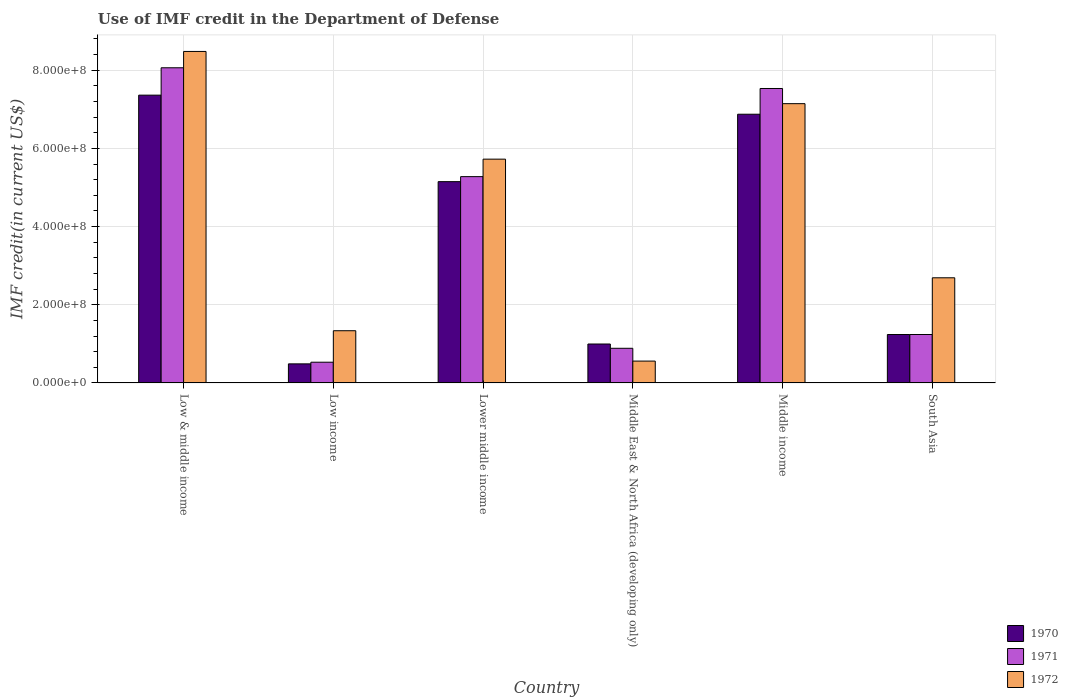How many different coloured bars are there?
Make the answer very short. 3. Are the number of bars per tick equal to the number of legend labels?
Provide a short and direct response. Yes. How many bars are there on the 6th tick from the left?
Ensure brevity in your answer.  3. What is the IMF credit in the Department of Defense in 1971 in Middle income?
Your answer should be compact. 7.53e+08. Across all countries, what is the maximum IMF credit in the Department of Defense in 1970?
Your answer should be compact. 7.36e+08. Across all countries, what is the minimum IMF credit in the Department of Defense in 1970?
Give a very brief answer. 4.88e+07. What is the total IMF credit in the Department of Defense in 1970 in the graph?
Your response must be concise. 2.21e+09. What is the difference between the IMF credit in the Department of Defense in 1971 in Low & middle income and that in Lower middle income?
Your answer should be very brief. 2.79e+08. What is the difference between the IMF credit in the Department of Defense in 1972 in South Asia and the IMF credit in the Department of Defense in 1970 in Middle East & North Africa (developing only)?
Your answer should be compact. 1.69e+08. What is the average IMF credit in the Department of Defense in 1972 per country?
Make the answer very short. 4.32e+08. What is the difference between the IMF credit in the Department of Defense of/in 1972 and IMF credit in the Department of Defense of/in 1970 in Middle East & North Africa (developing only)?
Make the answer very short. -4.37e+07. In how many countries, is the IMF credit in the Department of Defense in 1972 greater than 840000000 US$?
Provide a short and direct response. 1. What is the ratio of the IMF credit in the Department of Defense in 1970 in Low & middle income to that in Middle income?
Your answer should be very brief. 1.07. Is the difference between the IMF credit in the Department of Defense in 1972 in Low & middle income and Low income greater than the difference between the IMF credit in the Department of Defense in 1970 in Low & middle income and Low income?
Provide a succinct answer. Yes. What is the difference between the highest and the second highest IMF credit in the Department of Defense in 1972?
Provide a succinct answer. 1.34e+08. What is the difference between the highest and the lowest IMF credit in the Department of Defense in 1970?
Provide a succinct answer. 6.87e+08. What does the 2nd bar from the right in Low & middle income represents?
Offer a terse response. 1971. Is it the case that in every country, the sum of the IMF credit in the Department of Defense in 1971 and IMF credit in the Department of Defense in 1970 is greater than the IMF credit in the Department of Defense in 1972?
Offer a very short reply. No. Are all the bars in the graph horizontal?
Keep it short and to the point. No. How many countries are there in the graph?
Provide a short and direct response. 6. Does the graph contain any zero values?
Keep it short and to the point. No. Does the graph contain grids?
Provide a short and direct response. Yes. How many legend labels are there?
Your response must be concise. 3. What is the title of the graph?
Your answer should be compact. Use of IMF credit in the Department of Defense. Does "1980" appear as one of the legend labels in the graph?
Your answer should be very brief. No. What is the label or title of the X-axis?
Your answer should be very brief. Country. What is the label or title of the Y-axis?
Your answer should be very brief. IMF credit(in current US$). What is the IMF credit(in current US$) of 1970 in Low & middle income?
Offer a very short reply. 7.36e+08. What is the IMF credit(in current US$) of 1971 in Low & middle income?
Make the answer very short. 8.06e+08. What is the IMF credit(in current US$) in 1972 in Low & middle income?
Your answer should be compact. 8.48e+08. What is the IMF credit(in current US$) of 1970 in Low income?
Your answer should be compact. 4.88e+07. What is the IMF credit(in current US$) of 1971 in Low income?
Give a very brief answer. 5.30e+07. What is the IMF credit(in current US$) of 1972 in Low income?
Provide a succinct answer. 1.34e+08. What is the IMF credit(in current US$) in 1970 in Lower middle income?
Offer a terse response. 5.15e+08. What is the IMF credit(in current US$) in 1971 in Lower middle income?
Offer a very short reply. 5.28e+08. What is the IMF credit(in current US$) of 1972 in Lower middle income?
Ensure brevity in your answer.  5.73e+08. What is the IMF credit(in current US$) of 1970 in Middle East & North Africa (developing only)?
Give a very brief answer. 9.96e+07. What is the IMF credit(in current US$) of 1971 in Middle East & North Africa (developing only)?
Provide a short and direct response. 8.86e+07. What is the IMF credit(in current US$) in 1972 in Middle East & North Africa (developing only)?
Your answer should be very brief. 5.59e+07. What is the IMF credit(in current US$) in 1970 in Middle income?
Your answer should be compact. 6.87e+08. What is the IMF credit(in current US$) of 1971 in Middle income?
Your answer should be compact. 7.53e+08. What is the IMF credit(in current US$) in 1972 in Middle income?
Offer a terse response. 7.14e+08. What is the IMF credit(in current US$) in 1970 in South Asia?
Your response must be concise. 1.24e+08. What is the IMF credit(in current US$) of 1971 in South Asia?
Keep it short and to the point. 1.24e+08. What is the IMF credit(in current US$) in 1972 in South Asia?
Your response must be concise. 2.69e+08. Across all countries, what is the maximum IMF credit(in current US$) in 1970?
Your answer should be compact. 7.36e+08. Across all countries, what is the maximum IMF credit(in current US$) of 1971?
Offer a terse response. 8.06e+08. Across all countries, what is the maximum IMF credit(in current US$) in 1972?
Provide a succinct answer. 8.48e+08. Across all countries, what is the minimum IMF credit(in current US$) in 1970?
Provide a short and direct response. 4.88e+07. Across all countries, what is the minimum IMF credit(in current US$) in 1971?
Your answer should be compact. 5.30e+07. Across all countries, what is the minimum IMF credit(in current US$) of 1972?
Make the answer very short. 5.59e+07. What is the total IMF credit(in current US$) of 1970 in the graph?
Your answer should be very brief. 2.21e+09. What is the total IMF credit(in current US$) of 1971 in the graph?
Make the answer very short. 2.35e+09. What is the total IMF credit(in current US$) of 1972 in the graph?
Make the answer very short. 2.59e+09. What is the difference between the IMF credit(in current US$) of 1970 in Low & middle income and that in Low income?
Your answer should be compact. 6.87e+08. What is the difference between the IMF credit(in current US$) of 1971 in Low & middle income and that in Low income?
Ensure brevity in your answer.  7.53e+08. What is the difference between the IMF credit(in current US$) of 1972 in Low & middle income and that in Low income?
Your answer should be very brief. 7.14e+08. What is the difference between the IMF credit(in current US$) in 1970 in Low & middle income and that in Lower middle income?
Offer a very short reply. 2.21e+08. What is the difference between the IMF credit(in current US$) in 1971 in Low & middle income and that in Lower middle income?
Provide a short and direct response. 2.79e+08. What is the difference between the IMF credit(in current US$) of 1972 in Low & middle income and that in Lower middle income?
Give a very brief answer. 2.76e+08. What is the difference between the IMF credit(in current US$) of 1970 in Low & middle income and that in Middle East & North Africa (developing only)?
Make the answer very short. 6.37e+08. What is the difference between the IMF credit(in current US$) of 1971 in Low & middle income and that in Middle East & North Africa (developing only)?
Your response must be concise. 7.18e+08. What is the difference between the IMF credit(in current US$) of 1972 in Low & middle income and that in Middle East & North Africa (developing only)?
Your response must be concise. 7.92e+08. What is the difference between the IMF credit(in current US$) of 1970 in Low & middle income and that in Middle income?
Offer a terse response. 4.88e+07. What is the difference between the IMF credit(in current US$) in 1971 in Low & middle income and that in Middle income?
Offer a very short reply. 5.30e+07. What is the difference between the IMF credit(in current US$) in 1972 in Low & middle income and that in Middle income?
Your answer should be compact. 1.34e+08. What is the difference between the IMF credit(in current US$) of 1970 in Low & middle income and that in South Asia?
Make the answer very short. 6.12e+08. What is the difference between the IMF credit(in current US$) in 1971 in Low & middle income and that in South Asia?
Offer a terse response. 6.82e+08. What is the difference between the IMF credit(in current US$) of 1972 in Low & middle income and that in South Asia?
Keep it short and to the point. 5.79e+08. What is the difference between the IMF credit(in current US$) of 1970 in Low income and that in Lower middle income?
Your response must be concise. -4.66e+08. What is the difference between the IMF credit(in current US$) in 1971 in Low income and that in Lower middle income?
Provide a succinct answer. -4.75e+08. What is the difference between the IMF credit(in current US$) in 1972 in Low income and that in Lower middle income?
Make the answer very short. -4.39e+08. What is the difference between the IMF credit(in current US$) in 1970 in Low income and that in Middle East & North Africa (developing only)?
Offer a very short reply. -5.08e+07. What is the difference between the IMF credit(in current US$) in 1971 in Low income and that in Middle East & North Africa (developing only)?
Ensure brevity in your answer.  -3.56e+07. What is the difference between the IMF credit(in current US$) in 1972 in Low income and that in Middle East & North Africa (developing only)?
Offer a very short reply. 7.76e+07. What is the difference between the IMF credit(in current US$) of 1970 in Low income and that in Middle income?
Provide a short and direct response. -6.39e+08. What is the difference between the IMF credit(in current US$) of 1971 in Low income and that in Middle income?
Ensure brevity in your answer.  -7.00e+08. What is the difference between the IMF credit(in current US$) of 1972 in Low income and that in Middle income?
Your answer should be very brief. -5.81e+08. What is the difference between the IMF credit(in current US$) in 1970 in Low income and that in South Asia?
Give a very brief answer. -7.51e+07. What is the difference between the IMF credit(in current US$) in 1971 in Low income and that in South Asia?
Your response must be concise. -7.09e+07. What is the difference between the IMF credit(in current US$) of 1972 in Low income and that in South Asia?
Give a very brief answer. -1.35e+08. What is the difference between the IMF credit(in current US$) in 1970 in Lower middle income and that in Middle East & North Africa (developing only)?
Keep it short and to the point. 4.15e+08. What is the difference between the IMF credit(in current US$) in 1971 in Lower middle income and that in Middle East & North Africa (developing only)?
Make the answer very short. 4.39e+08. What is the difference between the IMF credit(in current US$) of 1972 in Lower middle income and that in Middle East & North Africa (developing only)?
Your response must be concise. 5.17e+08. What is the difference between the IMF credit(in current US$) of 1970 in Lower middle income and that in Middle income?
Keep it short and to the point. -1.72e+08. What is the difference between the IMF credit(in current US$) in 1971 in Lower middle income and that in Middle income?
Offer a terse response. -2.25e+08. What is the difference between the IMF credit(in current US$) of 1972 in Lower middle income and that in Middle income?
Keep it short and to the point. -1.42e+08. What is the difference between the IMF credit(in current US$) in 1970 in Lower middle income and that in South Asia?
Your response must be concise. 3.91e+08. What is the difference between the IMF credit(in current US$) of 1971 in Lower middle income and that in South Asia?
Your answer should be compact. 4.04e+08. What is the difference between the IMF credit(in current US$) of 1972 in Lower middle income and that in South Asia?
Offer a very short reply. 3.04e+08. What is the difference between the IMF credit(in current US$) of 1970 in Middle East & North Africa (developing only) and that in Middle income?
Your answer should be very brief. -5.88e+08. What is the difference between the IMF credit(in current US$) in 1971 in Middle East & North Africa (developing only) and that in Middle income?
Your response must be concise. -6.65e+08. What is the difference between the IMF credit(in current US$) in 1972 in Middle East & North Africa (developing only) and that in Middle income?
Provide a short and direct response. -6.59e+08. What is the difference between the IMF credit(in current US$) of 1970 in Middle East & North Africa (developing only) and that in South Asia?
Keep it short and to the point. -2.43e+07. What is the difference between the IMF credit(in current US$) of 1971 in Middle East & North Africa (developing only) and that in South Asia?
Provide a succinct answer. -3.53e+07. What is the difference between the IMF credit(in current US$) in 1972 in Middle East & North Africa (developing only) and that in South Asia?
Provide a short and direct response. -2.13e+08. What is the difference between the IMF credit(in current US$) of 1970 in Middle income and that in South Asia?
Your response must be concise. 5.64e+08. What is the difference between the IMF credit(in current US$) of 1971 in Middle income and that in South Asia?
Your answer should be very brief. 6.29e+08. What is the difference between the IMF credit(in current US$) in 1972 in Middle income and that in South Asia?
Offer a very short reply. 4.45e+08. What is the difference between the IMF credit(in current US$) of 1970 in Low & middle income and the IMF credit(in current US$) of 1971 in Low income?
Offer a terse response. 6.83e+08. What is the difference between the IMF credit(in current US$) of 1970 in Low & middle income and the IMF credit(in current US$) of 1972 in Low income?
Offer a terse response. 6.03e+08. What is the difference between the IMF credit(in current US$) in 1971 in Low & middle income and the IMF credit(in current US$) in 1972 in Low income?
Keep it short and to the point. 6.73e+08. What is the difference between the IMF credit(in current US$) in 1970 in Low & middle income and the IMF credit(in current US$) in 1971 in Lower middle income?
Make the answer very short. 2.08e+08. What is the difference between the IMF credit(in current US$) in 1970 in Low & middle income and the IMF credit(in current US$) in 1972 in Lower middle income?
Provide a succinct answer. 1.64e+08. What is the difference between the IMF credit(in current US$) of 1971 in Low & middle income and the IMF credit(in current US$) of 1972 in Lower middle income?
Make the answer very short. 2.34e+08. What is the difference between the IMF credit(in current US$) in 1970 in Low & middle income and the IMF credit(in current US$) in 1971 in Middle East & North Africa (developing only)?
Your answer should be very brief. 6.48e+08. What is the difference between the IMF credit(in current US$) in 1970 in Low & middle income and the IMF credit(in current US$) in 1972 in Middle East & North Africa (developing only)?
Your answer should be very brief. 6.80e+08. What is the difference between the IMF credit(in current US$) in 1971 in Low & middle income and the IMF credit(in current US$) in 1972 in Middle East & North Africa (developing only)?
Ensure brevity in your answer.  7.50e+08. What is the difference between the IMF credit(in current US$) of 1970 in Low & middle income and the IMF credit(in current US$) of 1971 in Middle income?
Your response must be concise. -1.70e+07. What is the difference between the IMF credit(in current US$) in 1970 in Low & middle income and the IMF credit(in current US$) in 1972 in Middle income?
Make the answer very short. 2.18e+07. What is the difference between the IMF credit(in current US$) in 1971 in Low & middle income and the IMF credit(in current US$) in 1972 in Middle income?
Your answer should be compact. 9.18e+07. What is the difference between the IMF credit(in current US$) in 1970 in Low & middle income and the IMF credit(in current US$) in 1971 in South Asia?
Offer a very short reply. 6.12e+08. What is the difference between the IMF credit(in current US$) in 1970 in Low & middle income and the IMF credit(in current US$) in 1972 in South Asia?
Give a very brief answer. 4.67e+08. What is the difference between the IMF credit(in current US$) in 1971 in Low & middle income and the IMF credit(in current US$) in 1972 in South Asia?
Provide a succinct answer. 5.37e+08. What is the difference between the IMF credit(in current US$) in 1970 in Low income and the IMF credit(in current US$) in 1971 in Lower middle income?
Your answer should be compact. -4.79e+08. What is the difference between the IMF credit(in current US$) in 1970 in Low income and the IMF credit(in current US$) in 1972 in Lower middle income?
Offer a terse response. -5.24e+08. What is the difference between the IMF credit(in current US$) of 1971 in Low income and the IMF credit(in current US$) of 1972 in Lower middle income?
Your answer should be very brief. -5.20e+08. What is the difference between the IMF credit(in current US$) in 1970 in Low income and the IMF credit(in current US$) in 1971 in Middle East & North Africa (developing only)?
Keep it short and to the point. -3.98e+07. What is the difference between the IMF credit(in current US$) in 1970 in Low income and the IMF credit(in current US$) in 1972 in Middle East & North Africa (developing only)?
Your answer should be very brief. -7.12e+06. What is the difference between the IMF credit(in current US$) in 1971 in Low income and the IMF credit(in current US$) in 1972 in Middle East & North Africa (developing only)?
Your answer should be compact. -2.90e+06. What is the difference between the IMF credit(in current US$) of 1970 in Low income and the IMF credit(in current US$) of 1971 in Middle income?
Provide a short and direct response. -7.04e+08. What is the difference between the IMF credit(in current US$) in 1970 in Low income and the IMF credit(in current US$) in 1972 in Middle income?
Keep it short and to the point. -6.66e+08. What is the difference between the IMF credit(in current US$) in 1971 in Low income and the IMF credit(in current US$) in 1972 in Middle income?
Your answer should be very brief. -6.61e+08. What is the difference between the IMF credit(in current US$) in 1970 in Low income and the IMF credit(in current US$) in 1971 in South Asia?
Your answer should be very brief. -7.51e+07. What is the difference between the IMF credit(in current US$) of 1970 in Low income and the IMF credit(in current US$) of 1972 in South Asia?
Provide a succinct answer. -2.20e+08. What is the difference between the IMF credit(in current US$) of 1971 in Low income and the IMF credit(in current US$) of 1972 in South Asia?
Offer a terse response. -2.16e+08. What is the difference between the IMF credit(in current US$) of 1970 in Lower middle income and the IMF credit(in current US$) of 1971 in Middle East & North Africa (developing only)?
Your answer should be very brief. 4.26e+08. What is the difference between the IMF credit(in current US$) in 1970 in Lower middle income and the IMF credit(in current US$) in 1972 in Middle East & North Africa (developing only)?
Provide a succinct answer. 4.59e+08. What is the difference between the IMF credit(in current US$) in 1971 in Lower middle income and the IMF credit(in current US$) in 1972 in Middle East & North Africa (developing only)?
Keep it short and to the point. 4.72e+08. What is the difference between the IMF credit(in current US$) of 1970 in Lower middle income and the IMF credit(in current US$) of 1971 in Middle income?
Your response must be concise. -2.38e+08. What is the difference between the IMF credit(in current US$) in 1970 in Lower middle income and the IMF credit(in current US$) in 1972 in Middle income?
Give a very brief answer. -2.00e+08. What is the difference between the IMF credit(in current US$) in 1971 in Lower middle income and the IMF credit(in current US$) in 1972 in Middle income?
Provide a short and direct response. -1.87e+08. What is the difference between the IMF credit(in current US$) of 1970 in Lower middle income and the IMF credit(in current US$) of 1971 in South Asia?
Offer a very short reply. 3.91e+08. What is the difference between the IMF credit(in current US$) of 1970 in Lower middle income and the IMF credit(in current US$) of 1972 in South Asia?
Provide a short and direct response. 2.46e+08. What is the difference between the IMF credit(in current US$) in 1971 in Lower middle income and the IMF credit(in current US$) in 1972 in South Asia?
Your answer should be compact. 2.59e+08. What is the difference between the IMF credit(in current US$) of 1970 in Middle East & North Africa (developing only) and the IMF credit(in current US$) of 1971 in Middle income?
Give a very brief answer. -6.54e+08. What is the difference between the IMF credit(in current US$) of 1970 in Middle East & North Africa (developing only) and the IMF credit(in current US$) of 1972 in Middle income?
Provide a short and direct response. -6.15e+08. What is the difference between the IMF credit(in current US$) in 1971 in Middle East & North Africa (developing only) and the IMF credit(in current US$) in 1972 in Middle income?
Provide a short and direct response. -6.26e+08. What is the difference between the IMF credit(in current US$) in 1970 in Middle East & North Africa (developing only) and the IMF credit(in current US$) in 1971 in South Asia?
Your answer should be very brief. -2.43e+07. What is the difference between the IMF credit(in current US$) in 1970 in Middle East & North Africa (developing only) and the IMF credit(in current US$) in 1972 in South Asia?
Your response must be concise. -1.69e+08. What is the difference between the IMF credit(in current US$) in 1971 in Middle East & North Africa (developing only) and the IMF credit(in current US$) in 1972 in South Asia?
Offer a very short reply. -1.80e+08. What is the difference between the IMF credit(in current US$) of 1970 in Middle income and the IMF credit(in current US$) of 1971 in South Asia?
Provide a succinct answer. 5.64e+08. What is the difference between the IMF credit(in current US$) of 1970 in Middle income and the IMF credit(in current US$) of 1972 in South Asia?
Give a very brief answer. 4.18e+08. What is the difference between the IMF credit(in current US$) in 1971 in Middle income and the IMF credit(in current US$) in 1972 in South Asia?
Give a very brief answer. 4.84e+08. What is the average IMF credit(in current US$) of 1970 per country?
Make the answer very short. 3.68e+08. What is the average IMF credit(in current US$) in 1971 per country?
Provide a short and direct response. 3.92e+08. What is the average IMF credit(in current US$) in 1972 per country?
Ensure brevity in your answer.  4.32e+08. What is the difference between the IMF credit(in current US$) in 1970 and IMF credit(in current US$) in 1971 in Low & middle income?
Offer a terse response. -7.00e+07. What is the difference between the IMF credit(in current US$) of 1970 and IMF credit(in current US$) of 1972 in Low & middle income?
Provide a succinct answer. -1.12e+08. What is the difference between the IMF credit(in current US$) in 1971 and IMF credit(in current US$) in 1972 in Low & middle income?
Provide a short and direct response. -4.18e+07. What is the difference between the IMF credit(in current US$) of 1970 and IMF credit(in current US$) of 1971 in Low income?
Your response must be concise. -4.21e+06. What is the difference between the IMF credit(in current US$) of 1970 and IMF credit(in current US$) of 1972 in Low income?
Your answer should be compact. -8.47e+07. What is the difference between the IMF credit(in current US$) of 1971 and IMF credit(in current US$) of 1972 in Low income?
Your answer should be compact. -8.05e+07. What is the difference between the IMF credit(in current US$) of 1970 and IMF credit(in current US$) of 1971 in Lower middle income?
Provide a short and direct response. -1.28e+07. What is the difference between the IMF credit(in current US$) in 1970 and IMF credit(in current US$) in 1972 in Lower middle income?
Offer a very short reply. -5.76e+07. What is the difference between the IMF credit(in current US$) of 1971 and IMF credit(in current US$) of 1972 in Lower middle income?
Offer a terse response. -4.48e+07. What is the difference between the IMF credit(in current US$) of 1970 and IMF credit(in current US$) of 1971 in Middle East & North Africa (developing only)?
Provide a succinct answer. 1.10e+07. What is the difference between the IMF credit(in current US$) of 1970 and IMF credit(in current US$) of 1972 in Middle East & North Africa (developing only)?
Offer a very short reply. 4.37e+07. What is the difference between the IMF credit(in current US$) in 1971 and IMF credit(in current US$) in 1972 in Middle East & North Africa (developing only)?
Your answer should be very brief. 3.27e+07. What is the difference between the IMF credit(in current US$) in 1970 and IMF credit(in current US$) in 1971 in Middle income?
Provide a succinct answer. -6.58e+07. What is the difference between the IMF credit(in current US$) of 1970 and IMF credit(in current US$) of 1972 in Middle income?
Provide a short and direct response. -2.71e+07. What is the difference between the IMF credit(in current US$) in 1971 and IMF credit(in current US$) in 1972 in Middle income?
Keep it short and to the point. 3.88e+07. What is the difference between the IMF credit(in current US$) in 1970 and IMF credit(in current US$) in 1972 in South Asia?
Offer a terse response. -1.45e+08. What is the difference between the IMF credit(in current US$) of 1971 and IMF credit(in current US$) of 1972 in South Asia?
Your response must be concise. -1.45e+08. What is the ratio of the IMF credit(in current US$) of 1970 in Low & middle income to that in Low income?
Your answer should be compact. 15.08. What is the ratio of the IMF credit(in current US$) in 1971 in Low & middle income to that in Low income?
Ensure brevity in your answer.  15.21. What is the ratio of the IMF credit(in current US$) of 1972 in Low & middle income to that in Low income?
Give a very brief answer. 6.35. What is the ratio of the IMF credit(in current US$) in 1970 in Low & middle income to that in Lower middle income?
Offer a very short reply. 1.43. What is the ratio of the IMF credit(in current US$) in 1971 in Low & middle income to that in Lower middle income?
Offer a very short reply. 1.53. What is the ratio of the IMF credit(in current US$) in 1972 in Low & middle income to that in Lower middle income?
Keep it short and to the point. 1.48. What is the ratio of the IMF credit(in current US$) of 1970 in Low & middle income to that in Middle East & North Africa (developing only)?
Provide a succinct answer. 7.39. What is the ratio of the IMF credit(in current US$) of 1971 in Low & middle income to that in Middle East & North Africa (developing only)?
Give a very brief answer. 9.1. What is the ratio of the IMF credit(in current US$) in 1972 in Low & middle income to that in Middle East & North Africa (developing only)?
Your answer should be very brief. 15.16. What is the ratio of the IMF credit(in current US$) in 1970 in Low & middle income to that in Middle income?
Your answer should be very brief. 1.07. What is the ratio of the IMF credit(in current US$) of 1971 in Low & middle income to that in Middle income?
Ensure brevity in your answer.  1.07. What is the ratio of the IMF credit(in current US$) of 1972 in Low & middle income to that in Middle income?
Provide a short and direct response. 1.19. What is the ratio of the IMF credit(in current US$) of 1970 in Low & middle income to that in South Asia?
Provide a succinct answer. 5.94. What is the ratio of the IMF credit(in current US$) in 1971 in Low & middle income to that in South Asia?
Provide a succinct answer. 6.51. What is the ratio of the IMF credit(in current US$) of 1972 in Low & middle income to that in South Asia?
Make the answer very short. 3.15. What is the ratio of the IMF credit(in current US$) in 1970 in Low income to that in Lower middle income?
Offer a very short reply. 0.09. What is the ratio of the IMF credit(in current US$) of 1971 in Low income to that in Lower middle income?
Provide a short and direct response. 0.1. What is the ratio of the IMF credit(in current US$) of 1972 in Low income to that in Lower middle income?
Keep it short and to the point. 0.23. What is the ratio of the IMF credit(in current US$) in 1970 in Low income to that in Middle East & North Africa (developing only)?
Offer a terse response. 0.49. What is the ratio of the IMF credit(in current US$) in 1971 in Low income to that in Middle East & North Africa (developing only)?
Ensure brevity in your answer.  0.6. What is the ratio of the IMF credit(in current US$) in 1972 in Low income to that in Middle East & North Africa (developing only)?
Your answer should be very brief. 2.39. What is the ratio of the IMF credit(in current US$) in 1970 in Low income to that in Middle income?
Ensure brevity in your answer.  0.07. What is the ratio of the IMF credit(in current US$) in 1971 in Low income to that in Middle income?
Keep it short and to the point. 0.07. What is the ratio of the IMF credit(in current US$) of 1972 in Low income to that in Middle income?
Offer a very short reply. 0.19. What is the ratio of the IMF credit(in current US$) of 1970 in Low income to that in South Asia?
Make the answer very short. 0.39. What is the ratio of the IMF credit(in current US$) of 1971 in Low income to that in South Asia?
Your answer should be compact. 0.43. What is the ratio of the IMF credit(in current US$) of 1972 in Low income to that in South Asia?
Your response must be concise. 0.5. What is the ratio of the IMF credit(in current US$) of 1970 in Lower middle income to that in Middle East & North Africa (developing only)?
Offer a very short reply. 5.17. What is the ratio of the IMF credit(in current US$) in 1971 in Lower middle income to that in Middle East & North Africa (developing only)?
Make the answer very short. 5.95. What is the ratio of the IMF credit(in current US$) in 1972 in Lower middle income to that in Middle East & North Africa (developing only)?
Ensure brevity in your answer.  10.24. What is the ratio of the IMF credit(in current US$) in 1970 in Lower middle income to that in Middle income?
Ensure brevity in your answer.  0.75. What is the ratio of the IMF credit(in current US$) in 1971 in Lower middle income to that in Middle income?
Make the answer very short. 0.7. What is the ratio of the IMF credit(in current US$) in 1972 in Lower middle income to that in Middle income?
Your response must be concise. 0.8. What is the ratio of the IMF credit(in current US$) in 1970 in Lower middle income to that in South Asia?
Provide a succinct answer. 4.16. What is the ratio of the IMF credit(in current US$) of 1971 in Lower middle income to that in South Asia?
Offer a very short reply. 4.26. What is the ratio of the IMF credit(in current US$) in 1972 in Lower middle income to that in South Asia?
Your answer should be compact. 2.13. What is the ratio of the IMF credit(in current US$) of 1970 in Middle East & North Africa (developing only) to that in Middle income?
Ensure brevity in your answer.  0.14. What is the ratio of the IMF credit(in current US$) in 1971 in Middle East & North Africa (developing only) to that in Middle income?
Ensure brevity in your answer.  0.12. What is the ratio of the IMF credit(in current US$) in 1972 in Middle East & North Africa (developing only) to that in Middle income?
Ensure brevity in your answer.  0.08. What is the ratio of the IMF credit(in current US$) in 1970 in Middle East & North Africa (developing only) to that in South Asia?
Your answer should be compact. 0.8. What is the ratio of the IMF credit(in current US$) in 1971 in Middle East & North Africa (developing only) to that in South Asia?
Your answer should be very brief. 0.72. What is the ratio of the IMF credit(in current US$) in 1972 in Middle East & North Africa (developing only) to that in South Asia?
Keep it short and to the point. 0.21. What is the ratio of the IMF credit(in current US$) of 1970 in Middle income to that in South Asia?
Your response must be concise. 5.55. What is the ratio of the IMF credit(in current US$) of 1971 in Middle income to that in South Asia?
Your response must be concise. 6.08. What is the ratio of the IMF credit(in current US$) of 1972 in Middle income to that in South Asia?
Your answer should be compact. 2.66. What is the difference between the highest and the second highest IMF credit(in current US$) of 1970?
Ensure brevity in your answer.  4.88e+07. What is the difference between the highest and the second highest IMF credit(in current US$) of 1971?
Offer a terse response. 5.30e+07. What is the difference between the highest and the second highest IMF credit(in current US$) of 1972?
Your response must be concise. 1.34e+08. What is the difference between the highest and the lowest IMF credit(in current US$) in 1970?
Your answer should be very brief. 6.87e+08. What is the difference between the highest and the lowest IMF credit(in current US$) in 1971?
Give a very brief answer. 7.53e+08. What is the difference between the highest and the lowest IMF credit(in current US$) of 1972?
Give a very brief answer. 7.92e+08. 